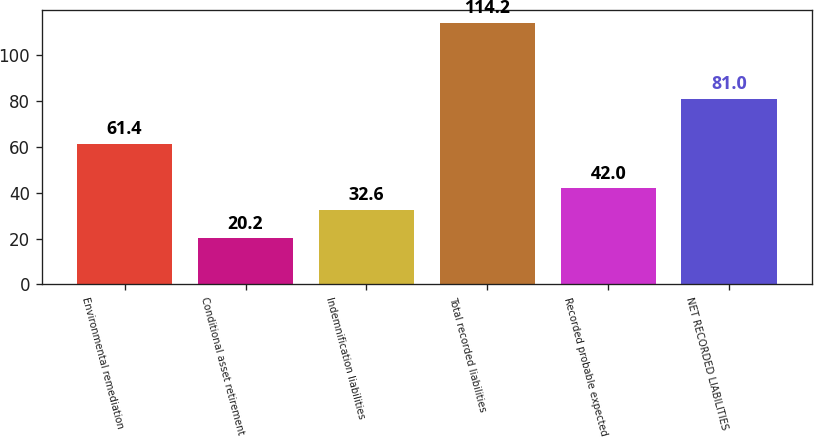<chart> <loc_0><loc_0><loc_500><loc_500><bar_chart><fcel>Environmental remediation<fcel>Conditional asset retirement<fcel>Indemnification liabilities<fcel>Total recorded liabilities<fcel>Recorded probable expected<fcel>NET RECORDED LIABILITIES<nl><fcel>61.4<fcel>20.2<fcel>32.6<fcel>114.2<fcel>42<fcel>81<nl></chart> 